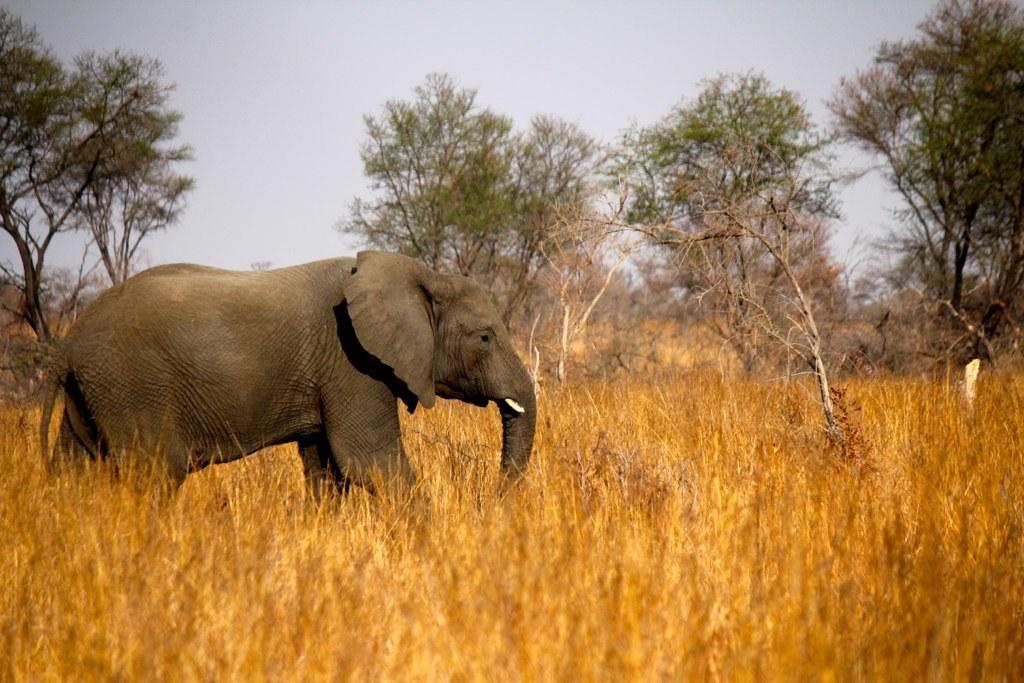Please provide a concise description of this image. This is the picture of an elephant which is walking in the field. The field has grass all over the land. And there are some trees in the background. We can observe a sky here. 